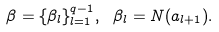Convert formula to latex. <formula><loc_0><loc_0><loc_500><loc_500>\beta = \{ \beta _ { l } \} _ { l = 1 } ^ { q - 1 } , \ \beta _ { l } = N ( a _ { l + 1 } ) .</formula> 